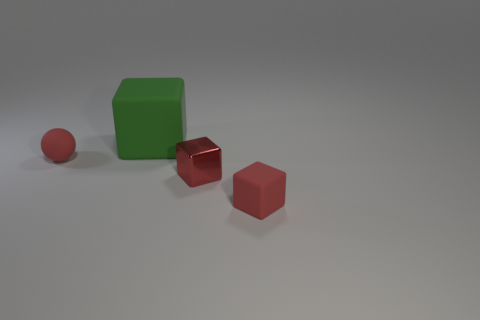If we were to add another object into this scene to make it more dynamic, what would you suggest? Introducing a translucent object, like a glass pyramid, could add a dynamic element to the scene. Its transparency and refraction would contrast with the solid colors and matte materials, while also interacting interestingly with the current lighting setup. 